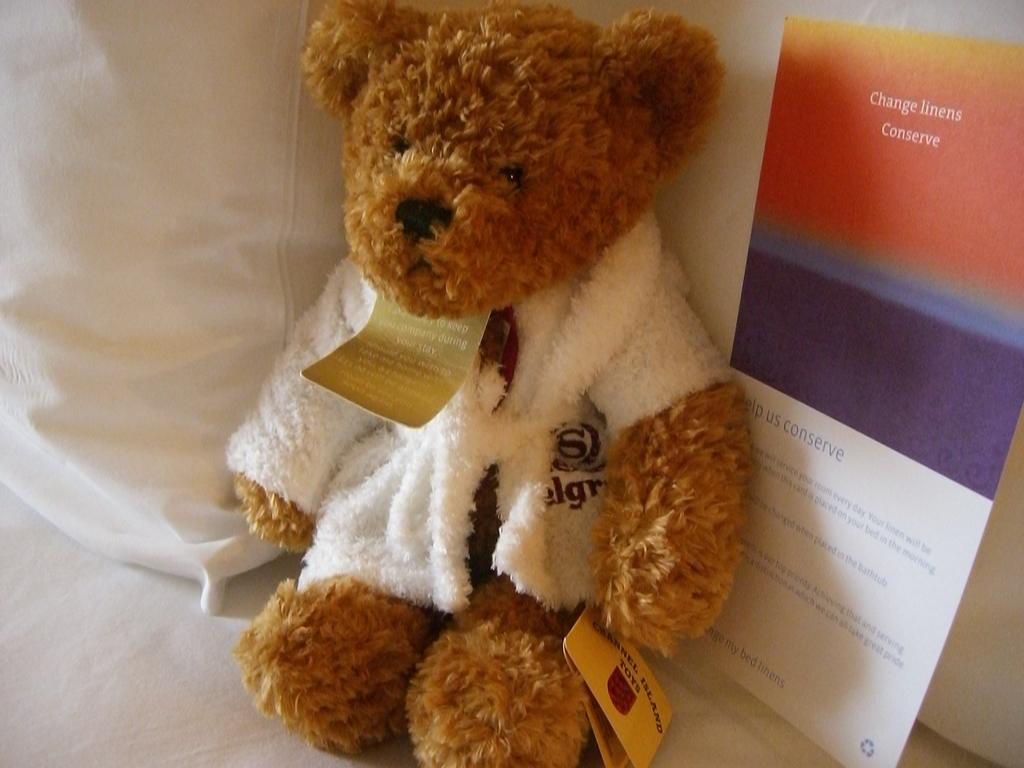How would you summarize this image in a sentence or two? The teddy is highlighted in this picture. The teddy is in brown color. The teddy wore white jacket. It is sitting on a white cloth. Beside this teddy there is a card. 